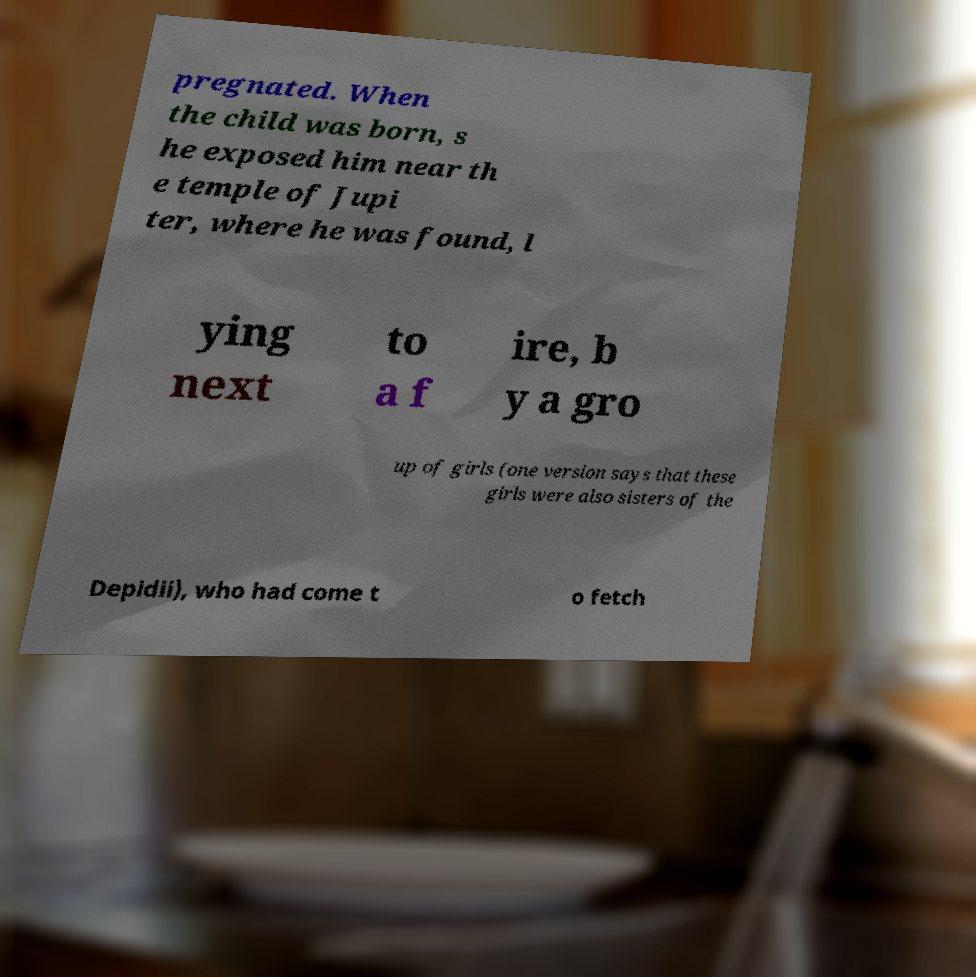Please identify and transcribe the text found in this image. pregnated. When the child was born, s he exposed him near th e temple of Jupi ter, where he was found, l ying next to a f ire, b y a gro up of girls (one version says that these girls were also sisters of the Depidii), who had come t o fetch 